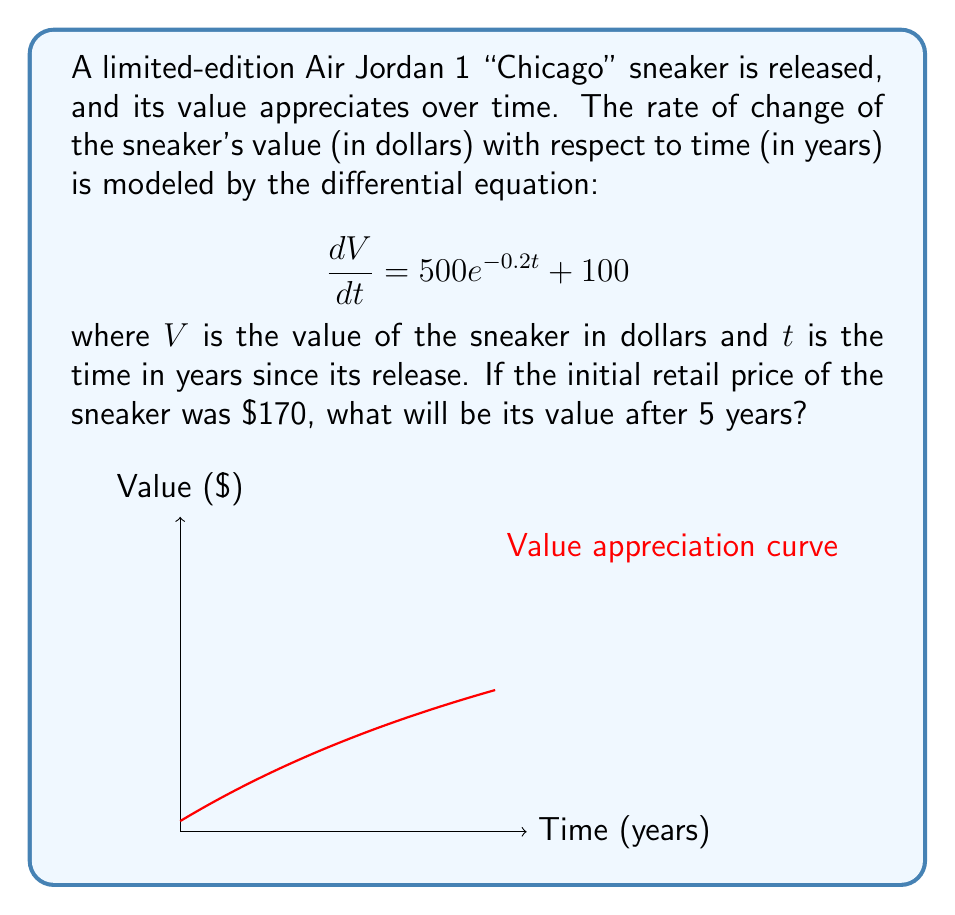Show me your answer to this math problem. Let's solve this step-by-step:

1) We're given the differential equation:
   $$\frac{dV}{dt} = 500e^{-0.2t} + 100$$

2) To find $V(t)$, we need to integrate both sides:
   $$V = \int (500e^{-0.2t} + 100) dt$$

3) Integrating the right side:
   $$V = -2500e^{-0.2t} + 100t + C$$

4) We need to find the constant of integration $C$ using the initial condition. At $t=0$, $V=170$:
   $$170 = -2500 + 0 + C$$
   $$C = 2670$$

5) So, our solution is:
   $$V(t) = -2500e^{-0.2t} + 100t + 2670$$

6) To find the value after 5 years, we substitute $t=5$:
   $$V(5) = -2500e^{-0.2(5)} + 100(5) + 2670$$
   $$= -2500(0.36788) + 500 + 2670$$
   $$= -919.7 + 500 + 2670$$
   $$= 2250.3$$

Therefore, after 5 years, the sneaker's value will be approximately $2,250.30.
Answer: $2,250.30 